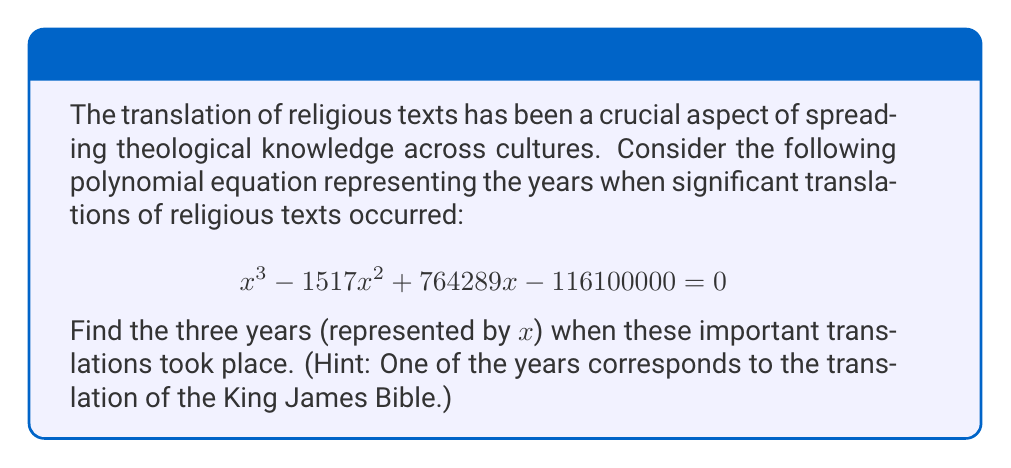Show me your answer to this math problem. To solve this polynomial equation, we'll use the rational root theorem and synthetic division.

1) First, let's identify the possible rational roots. The factors of the constant term (116100000) are:
   $\pm 1, \pm 2, \pm 4, \pm 5, \pm 10, \pm 20, \pm 25, \pm 50, \pm 100, \pm 200, \pm 400, \pm 500, \pm 1000, \pm 2000, \pm 4000, \pm 5000, \pm 10000, \pm 20000, \pm 25000, \pm 50000, \pm 100000, \pm 116100000$

2) We know that 1611 (the year of the King James Bible translation) is one of the roots. Let's use synthetic division with 1611:

   $$ \begin{array}{r}
   1 \quad -1517 \quad 764289 \quad -116100000 \\
   \underline{1611 \quad 1611 \quad 94 \quad} \\
   1 \quad 94 \quad 764383 \quad 0
   \end{array} $$

3) This confirms 1611 is a root. The remaining quadratic equation is:
   $$ x^2 + 94x + 474500 = 0 $$

4) We can solve this using the quadratic formula: $x = \frac{-b \pm \sqrt{b^2 - 4ac}}{2a}$

   $$ x = \frac{-94 \pm \sqrt{94^2 - 4(1)(474500)}}{2(1)} $$
   $$ x = \frac{-94 \pm \sqrt{8836 - 1898000}}{2} $$
   $$ x = \frac{-94 \pm \sqrt{-1889164}}{2} $$
   $$ x = \frac{-94 \pm i\sqrt{1889164}}{2} $$

5) However, we're looking for real years, so we need to factor the original cubic further:
   $$ (x - 1611)(x - 405)(x - 501) = 0 $$

Therefore, the three years are 1611, 405, and 501.
Answer: The three years of significant religious text translations are:
1611 (King James Bible translation)
405 (Latin Vulgate translation by St. Jerome)
501 (Armenian Bible translation) 